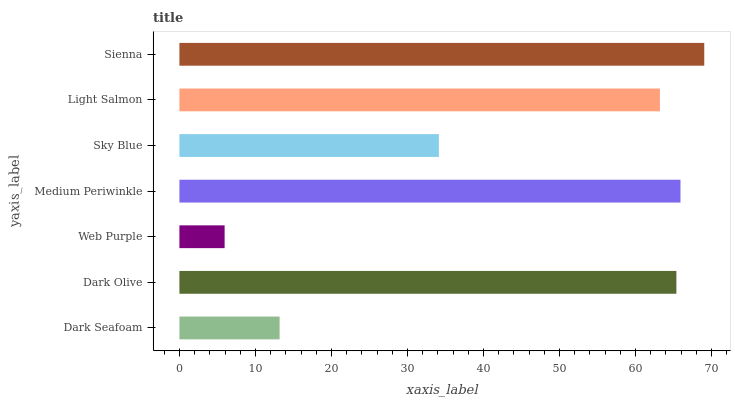Is Web Purple the minimum?
Answer yes or no. Yes. Is Sienna the maximum?
Answer yes or no. Yes. Is Dark Olive the minimum?
Answer yes or no. No. Is Dark Olive the maximum?
Answer yes or no. No. Is Dark Olive greater than Dark Seafoam?
Answer yes or no. Yes. Is Dark Seafoam less than Dark Olive?
Answer yes or no. Yes. Is Dark Seafoam greater than Dark Olive?
Answer yes or no. No. Is Dark Olive less than Dark Seafoam?
Answer yes or no. No. Is Light Salmon the high median?
Answer yes or no. Yes. Is Light Salmon the low median?
Answer yes or no. Yes. Is Dark Olive the high median?
Answer yes or no. No. Is Sky Blue the low median?
Answer yes or no. No. 